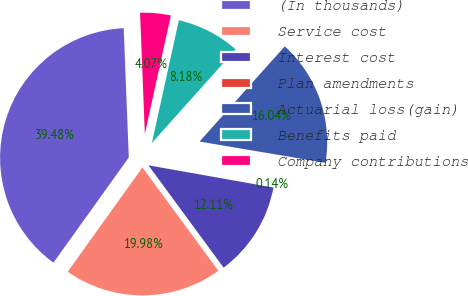Convert chart. <chart><loc_0><loc_0><loc_500><loc_500><pie_chart><fcel>(In thousands)<fcel>Service cost<fcel>Interest cost<fcel>Plan amendments<fcel>Actuarial loss(gain)<fcel>Benefits paid<fcel>Company contributions<nl><fcel>39.48%<fcel>19.98%<fcel>12.11%<fcel>0.14%<fcel>16.04%<fcel>8.18%<fcel>4.07%<nl></chart> 